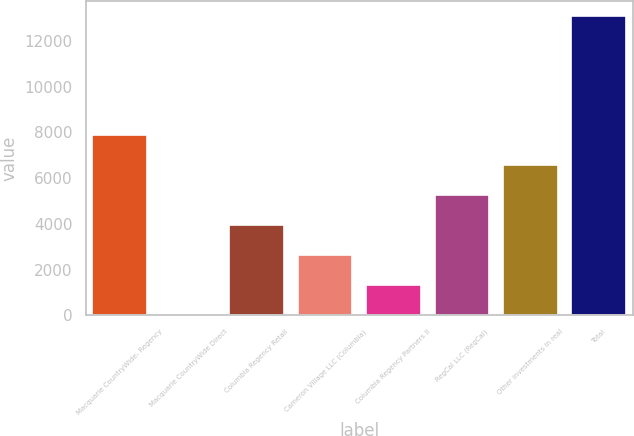Convert chart. <chart><loc_0><loc_0><loc_500><loc_500><bar_chart><fcel>Macquarie CountryWide- Regency<fcel>Macquarie CountryWide Direct<fcel>Columbia Regency Retail<fcel>Cameron Village LLC (Columbia)<fcel>Columbia Regency Partners II<fcel>RegCal LLC (RegCal)<fcel>Other investments in real<fcel>Total<nl><fcel>7878.4<fcel>43<fcel>3960.7<fcel>2654.8<fcel>1348.9<fcel>5266.6<fcel>6572.5<fcel>13102<nl></chart> 